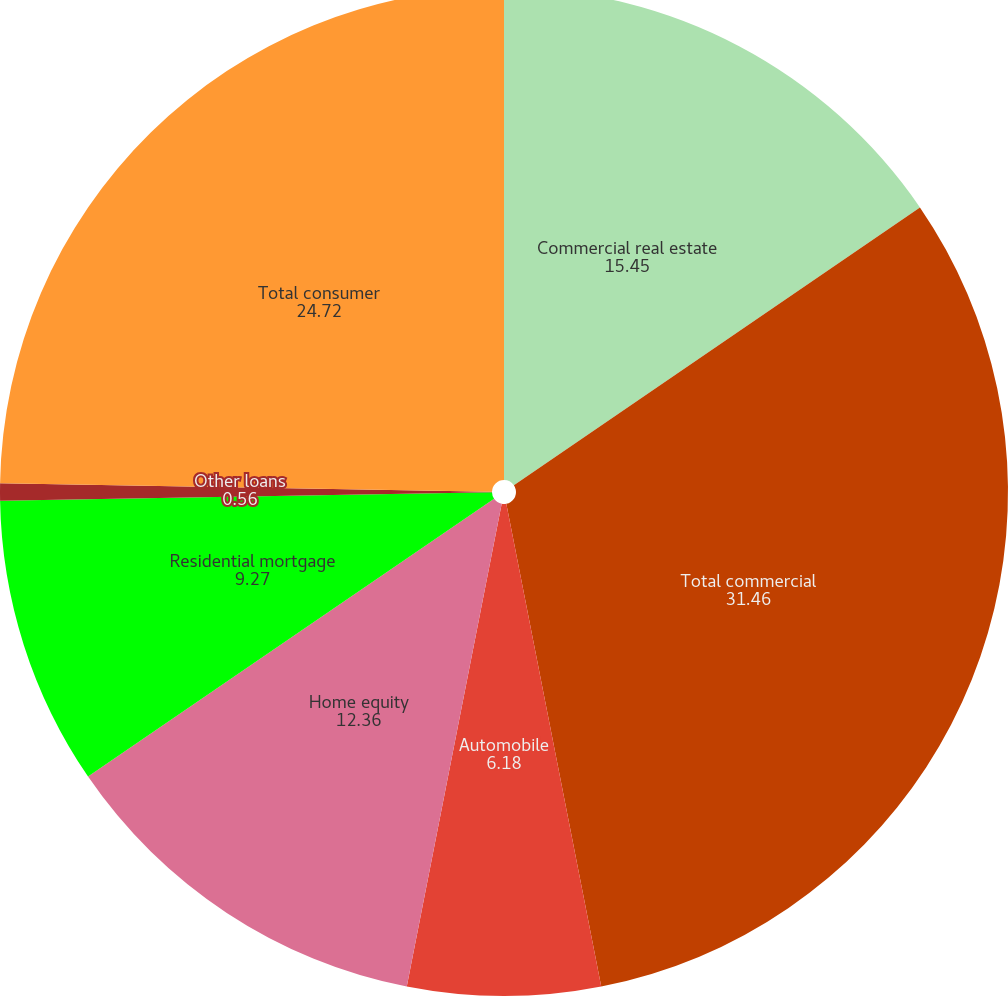Convert chart to OTSL. <chart><loc_0><loc_0><loc_500><loc_500><pie_chart><fcel>Commercial real estate<fcel>Total commercial<fcel>Automobile<fcel>Home equity<fcel>Residential mortgage<fcel>Other loans<fcel>Total consumer<nl><fcel>15.45%<fcel>31.46%<fcel>6.18%<fcel>12.36%<fcel>9.27%<fcel>0.56%<fcel>24.72%<nl></chart> 